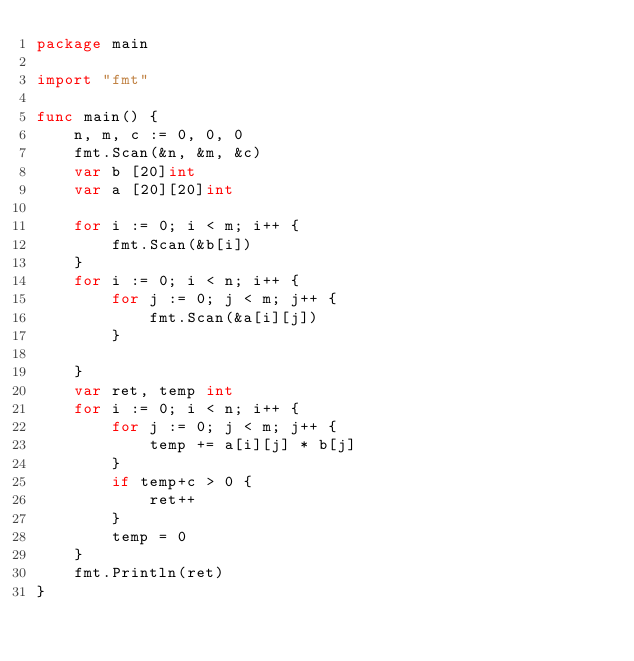Convert code to text. <code><loc_0><loc_0><loc_500><loc_500><_Go_>package main

import "fmt"

func main() {
	n, m, c := 0, 0, 0
	fmt.Scan(&n, &m, &c)
	var b [20]int
	var a [20][20]int

	for i := 0; i < m; i++ {
		fmt.Scan(&b[i])
	}
	for i := 0; i < n; i++ {
		for j := 0; j < m; j++ {
			fmt.Scan(&a[i][j])
		}

	}
	var ret, temp int
	for i := 0; i < n; i++ {
		for j := 0; j < m; j++ {
			temp += a[i][j] * b[j]
		}
		if temp+c > 0 {
			ret++
		}
		temp = 0
	}
	fmt.Println(ret)
}
</code> 